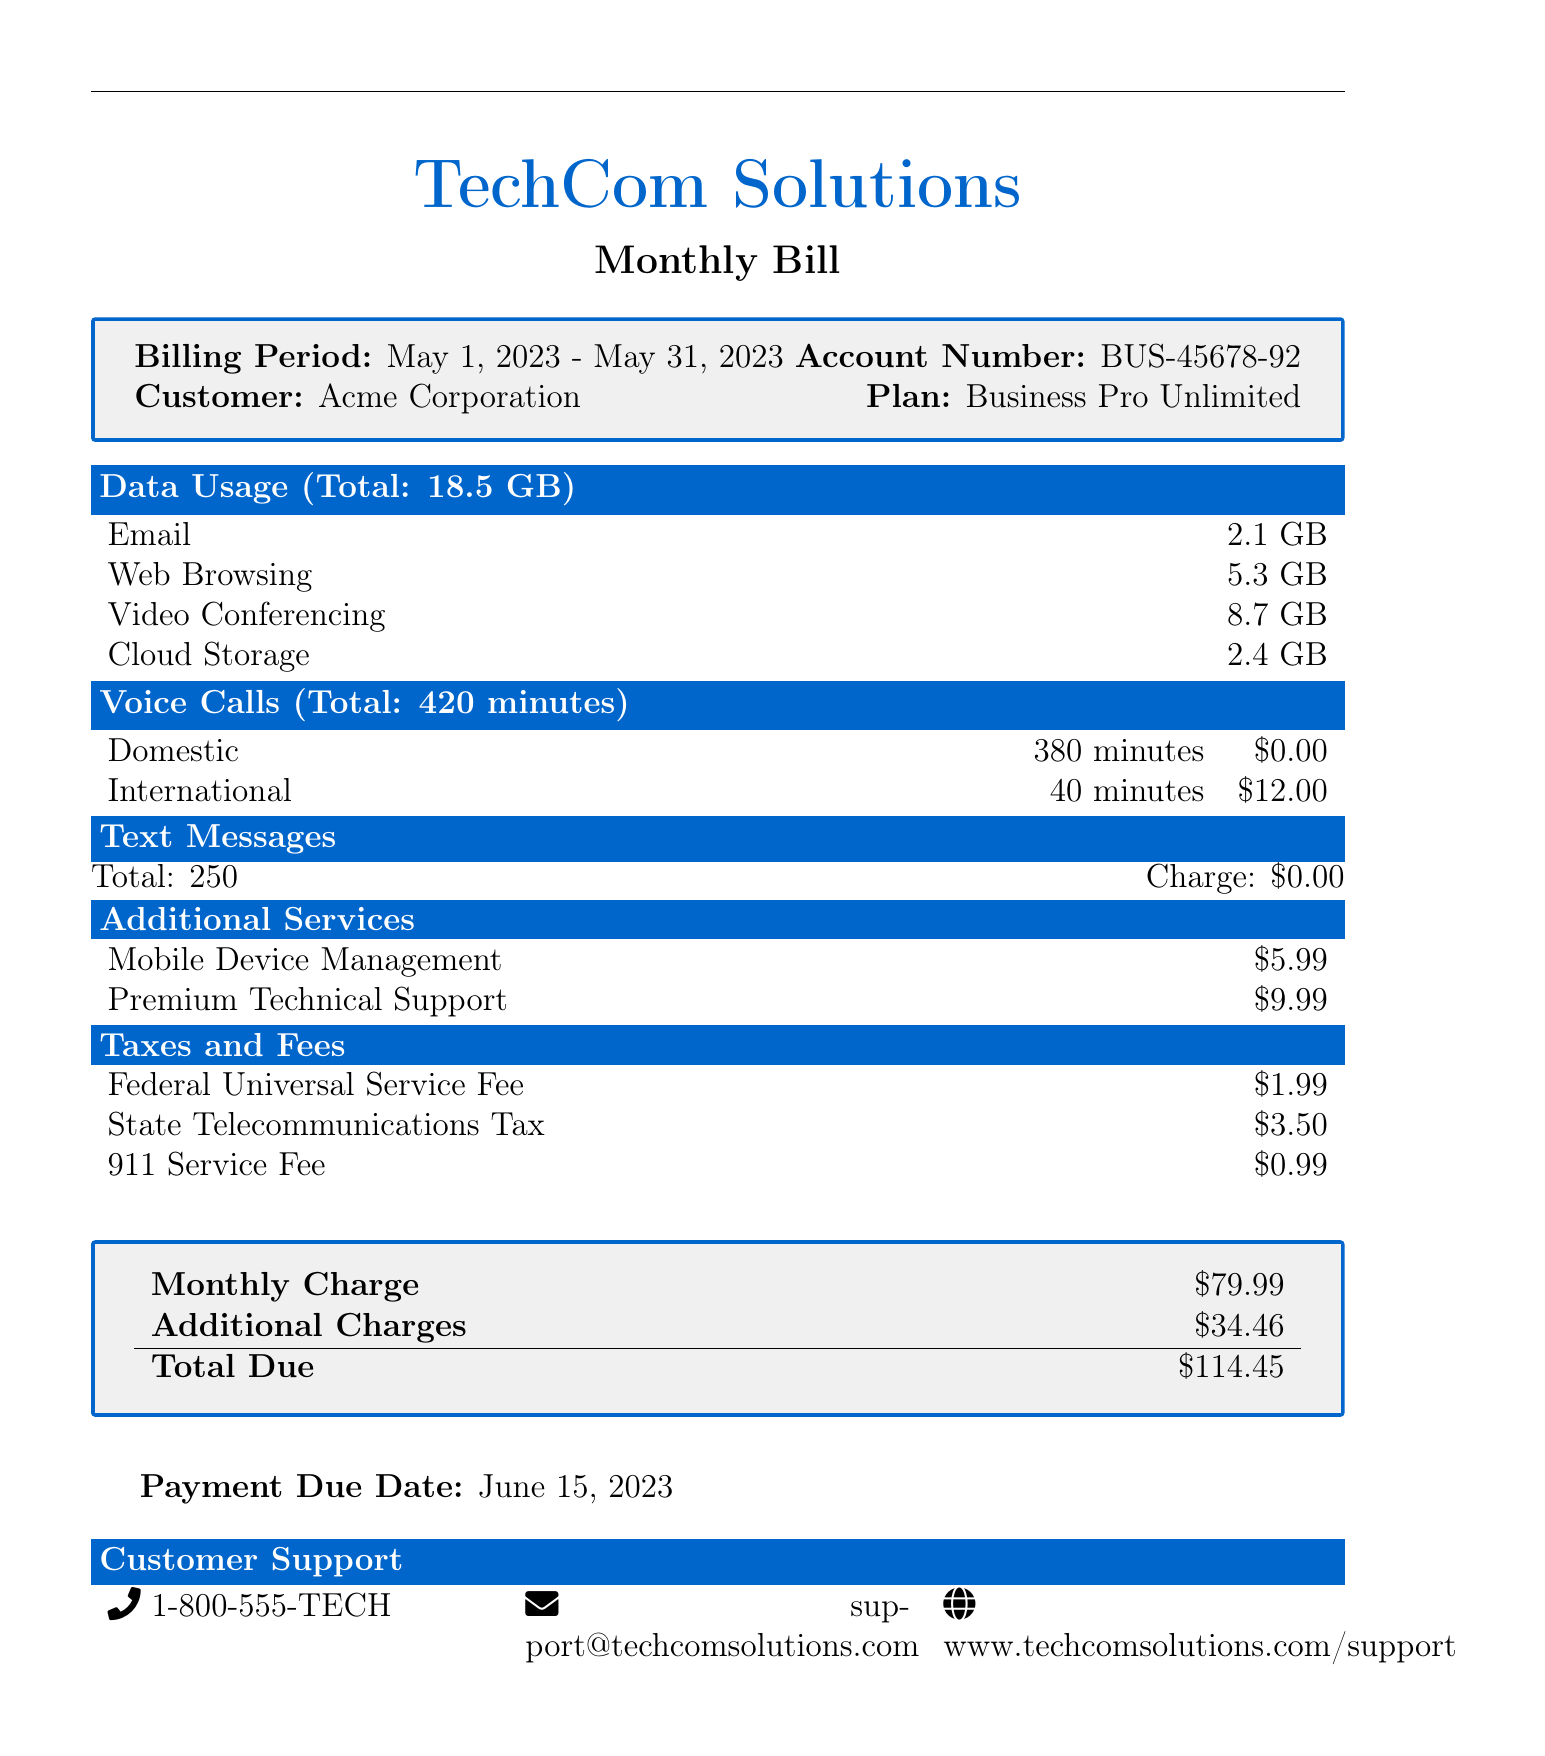what is the billing period? The billing period is the duration for which the bill is calculated, stated as May 1, 2023 - May 31, 2023.
Answer: May 1, 2023 - May 31, 2023 what is the total data usage? The total data usage combines all types of data consumed, which is shown as 18.5 GB.
Answer: 18.5 GB how many minutes were used for international calls? The document specifies the total minutes used for international calls as 40 minutes.
Answer: 40 minutes what is the charge for mobile device management? The charge for mobile device management is listed in the additional services section as $5.99.
Answer: $5.99 how much is the total due for this bill? The total due is the final amount including monthly charge and additional charges, which adds up to $114.45.
Answer: $114.45 what is the account number? The account number is a unique identifier for billing purposes, which is given as BUS-45678-92.
Answer: BUS-45678-92 how much was charged for state telecommunications tax? The charge for state telecommunications tax is specified directly in the taxes and fees section as $3.50.
Answer: $3.50 who is the customer? The customer name is listed at the beginning of the document, which is Acme Corporation.
Answer: Acme Corporation what is the payment due date? The payment due date marks the deadline for the bill payment and is stated as June 15, 2023.
Answer: June 15, 2023 